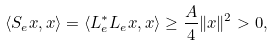Convert formula to latex. <formula><loc_0><loc_0><loc_500><loc_500>\langle S _ { e } x , x \rangle = \langle L _ { e } ^ { * } L _ { e } x , x \rangle \geq \frac { A } { 4 } \| x \| ^ { 2 } > 0 ,</formula> 